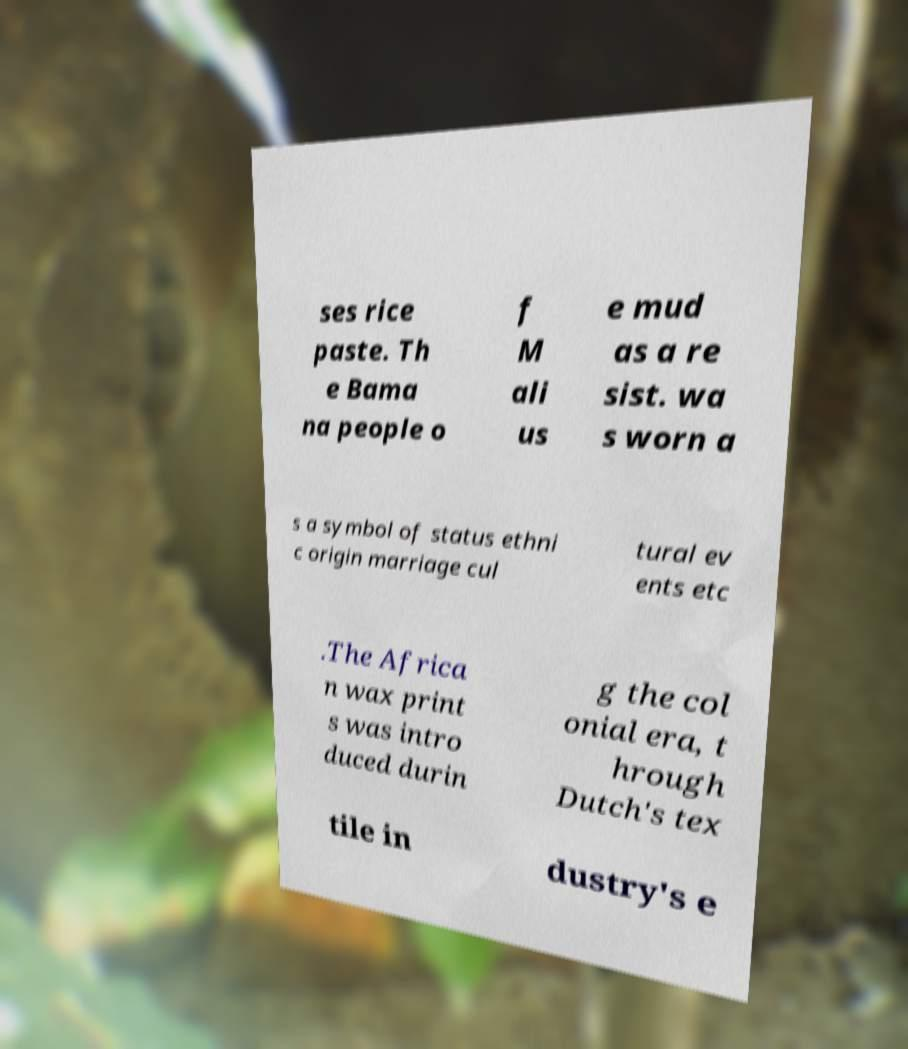Please identify and transcribe the text found in this image. ses rice paste. Th e Bama na people o f M ali us e mud as a re sist. wa s worn a s a symbol of status ethni c origin marriage cul tural ev ents etc .The Africa n wax print s was intro duced durin g the col onial era, t hrough Dutch's tex tile in dustry's e 